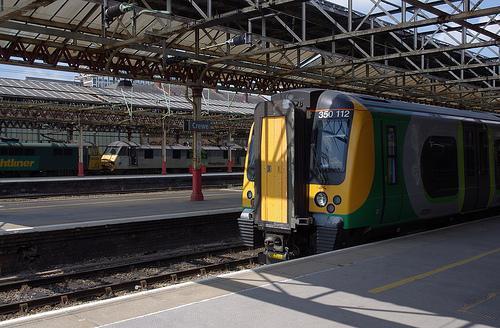How many trains at the platform?
Give a very brief answer. 2. How many train cars are completely in the sun?
Give a very brief answer. 0. 